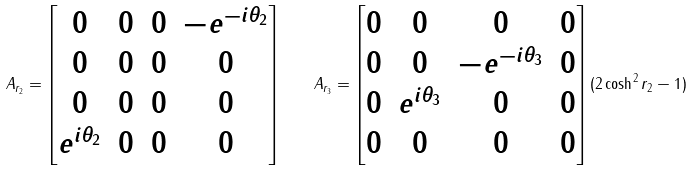<formula> <loc_0><loc_0><loc_500><loc_500>A _ { r _ { 2 } } = \left [ \begin{matrix} 0 & 0 & 0 & - e ^ { - i \theta _ { 2 } } \\ 0 & 0 & 0 & 0 \\ 0 & 0 & 0 & 0 \\ e ^ { i \theta _ { 2 } } & 0 & 0 & 0 \end{matrix} \right ] \quad A _ { r _ { 3 } } = \left [ \begin{matrix} 0 & 0 & 0 & 0 \\ 0 & 0 & - e ^ { - i \theta _ { 3 } } & 0 \\ 0 & e ^ { i \theta _ { 3 } } & 0 & 0 \\ 0 & 0 & 0 & 0 \\ \end{matrix} \right ] ( 2 \cosh ^ { 2 } r _ { 2 } - 1 )</formula> 